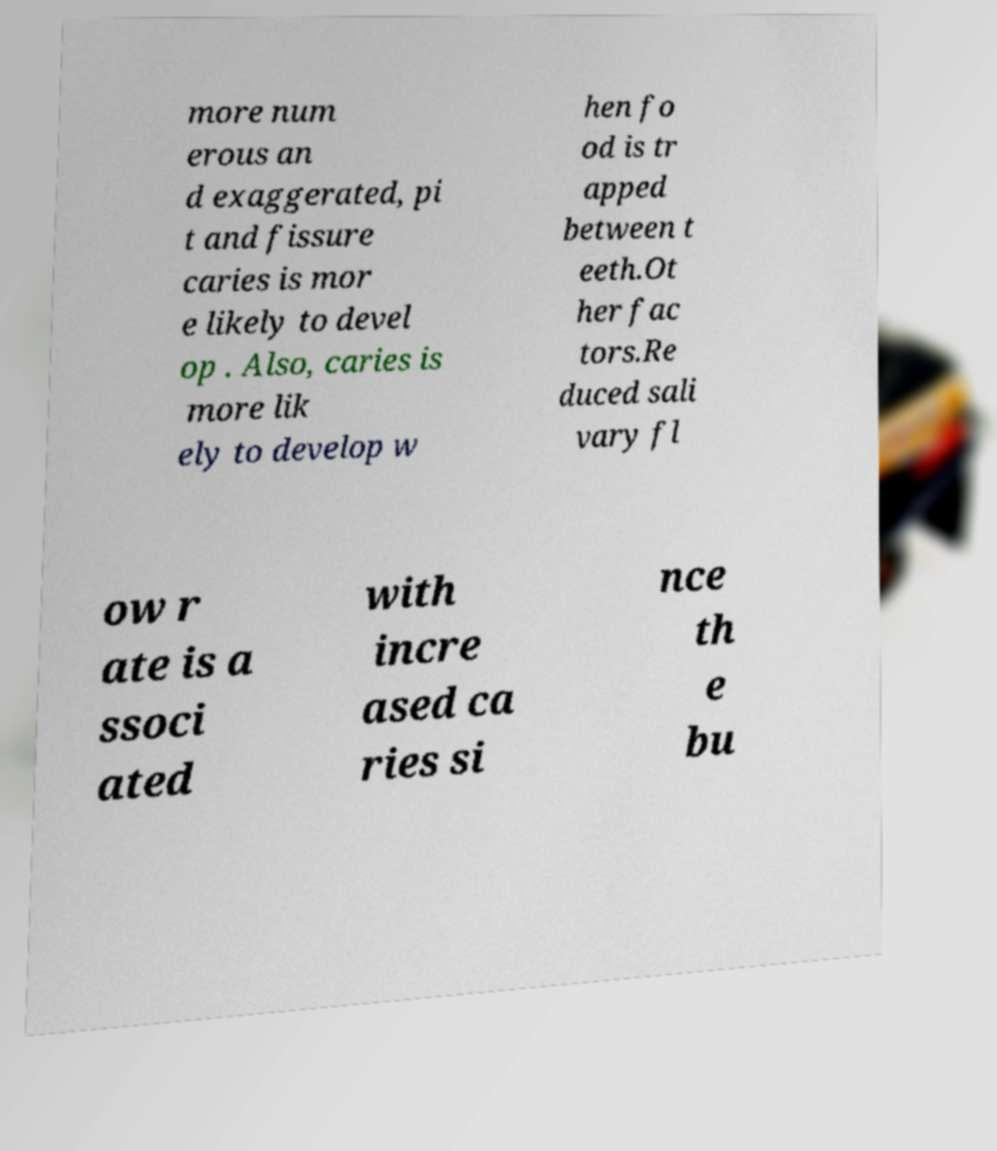I need the written content from this picture converted into text. Can you do that? more num erous an d exaggerated, pi t and fissure caries is mor e likely to devel op . Also, caries is more lik ely to develop w hen fo od is tr apped between t eeth.Ot her fac tors.Re duced sali vary fl ow r ate is a ssoci ated with incre ased ca ries si nce th e bu 